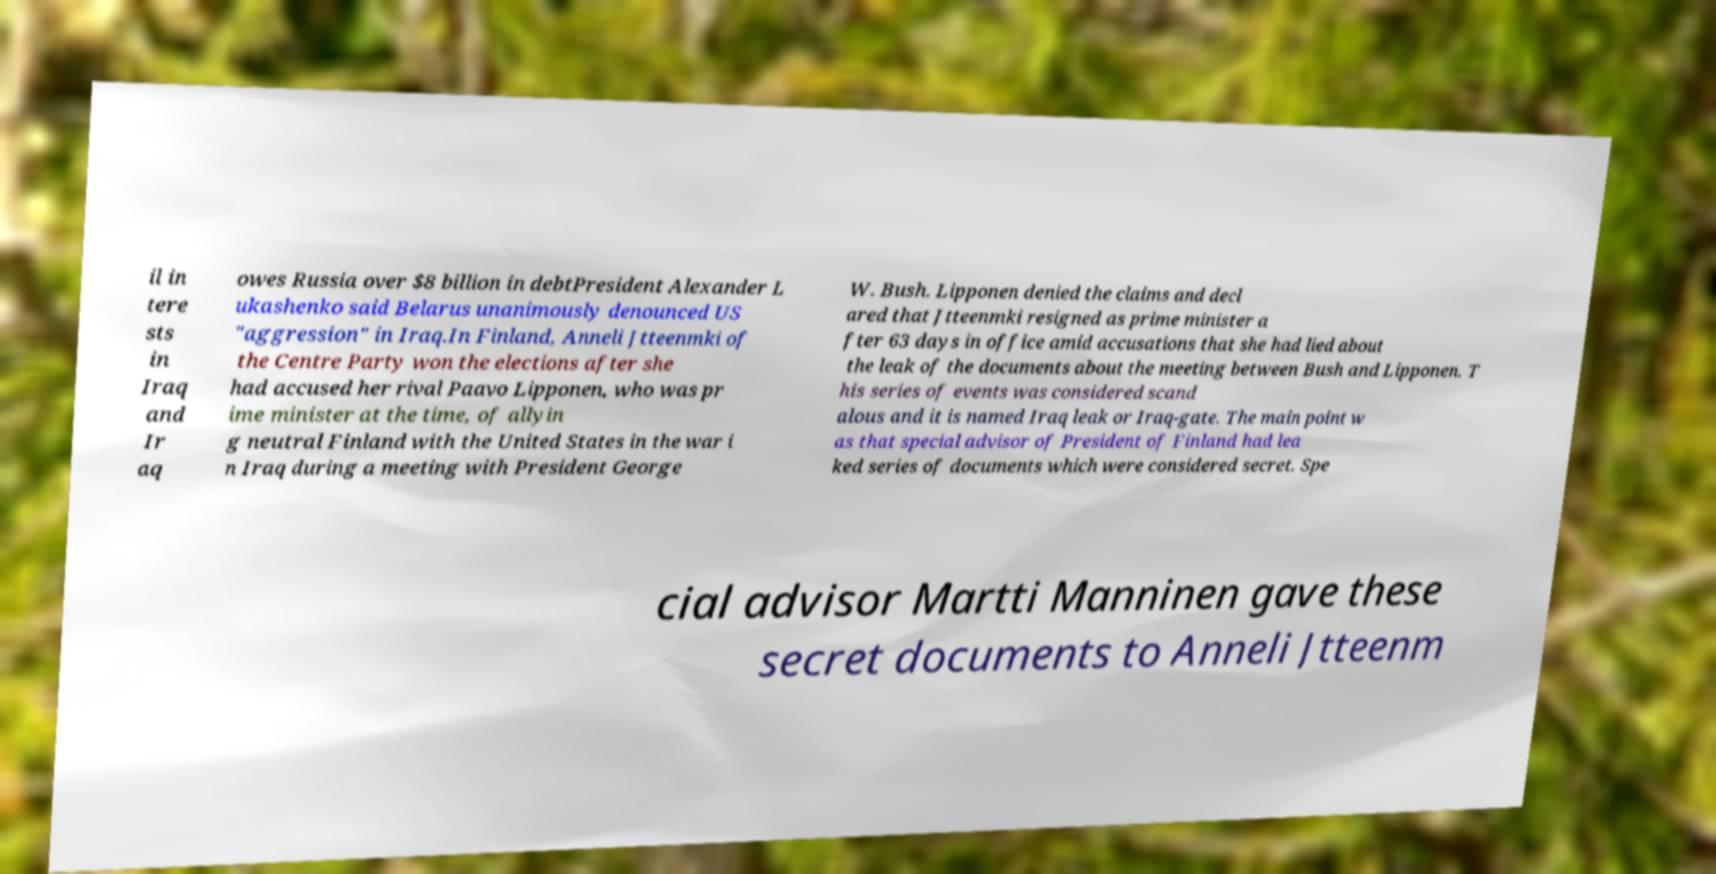I need the written content from this picture converted into text. Can you do that? il in tere sts in Iraq and Ir aq owes Russia over $8 billion in debtPresident Alexander L ukashenko said Belarus unanimously denounced US "aggression" in Iraq.In Finland, Anneli Jtteenmki of the Centre Party won the elections after she had accused her rival Paavo Lipponen, who was pr ime minister at the time, of allyin g neutral Finland with the United States in the war i n Iraq during a meeting with President George W. Bush. Lipponen denied the claims and decl ared that Jtteenmki resigned as prime minister a fter 63 days in office amid accusations that she had lied about the leak of the documents about the meeting between Bush and Lipponen. T his series of events was considered scand alous and it is named Iraq leak or Iraq-gate. The main point w as that special advisor of President of Finland had lea ked series of documents which were considered secret. Spe cial advisor Martti Manninen gave these secret documents to Anneli Jtteenm 